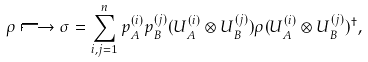Convert formula to latex. <formula><loc_0><loc_0><loc_500><loc_500>\rho \longmapsto \sigma = \sum _ { i , j = 1 } ^ { n } p ^ { ( i ) } _ { A } p ^ { ( j ) } _ { B } ( U _ { A } ^ { ( i ) } \otimes U _ { B } ^ { ( j ) } ) \rho ( U _ { A } ^ { ( i ) } \otimes U _ { B } ^ { ( j ) } ) ^ { \dagger } ,</formula> 